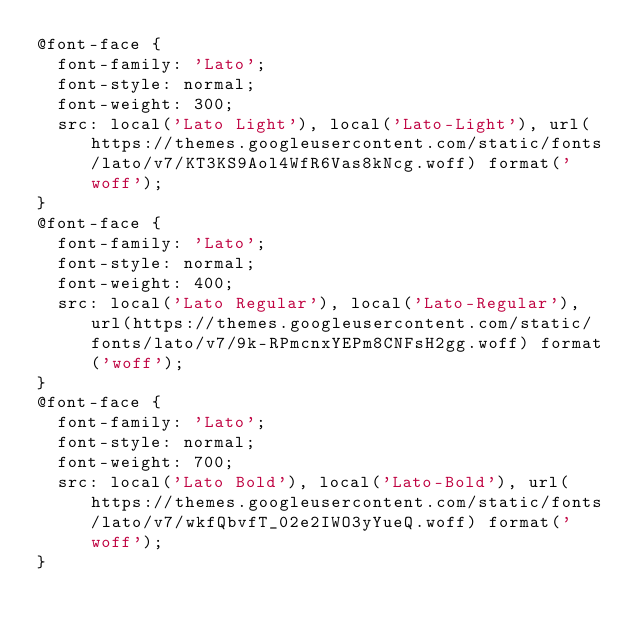Convert code to text. <code><loc_0><loc_0><loc_500><loc_500><_CSS_>@font-face {
  font-family: 'Lato';
  font-style: normal;
  font-weight: 300;
  src: local('Lato Light'), local('Lato-Light'), url(https://themes.googleusercontent.com/static/fonts/lato/v7/KT3KS9Aol4WfR6Vas8kNcg.woff) format('woff');
}
@font-face {
  font-family: 'Lato';
  font-style: normal;
  font-weight: 400;
  src: local('Lato Regular'), local('Lato-Regular'), url(https://themes.googleusercontent.com/static/fonts/lato/v7/9k-RPmcnxYEPm8CNFsH2gg.woff) format('woff');
}
@font-face {
  font-family: 'Lato';
  font-style: normal;
  font-weight: 700;
  src: local('Lato Bold'), local('Lato-Bold'), url(https://themes.googleusercontent.com/static/fonts/lato/v7/wkfQbvfT_02e2IWO3yYueQ.woff) format('woff');
}
</code> 